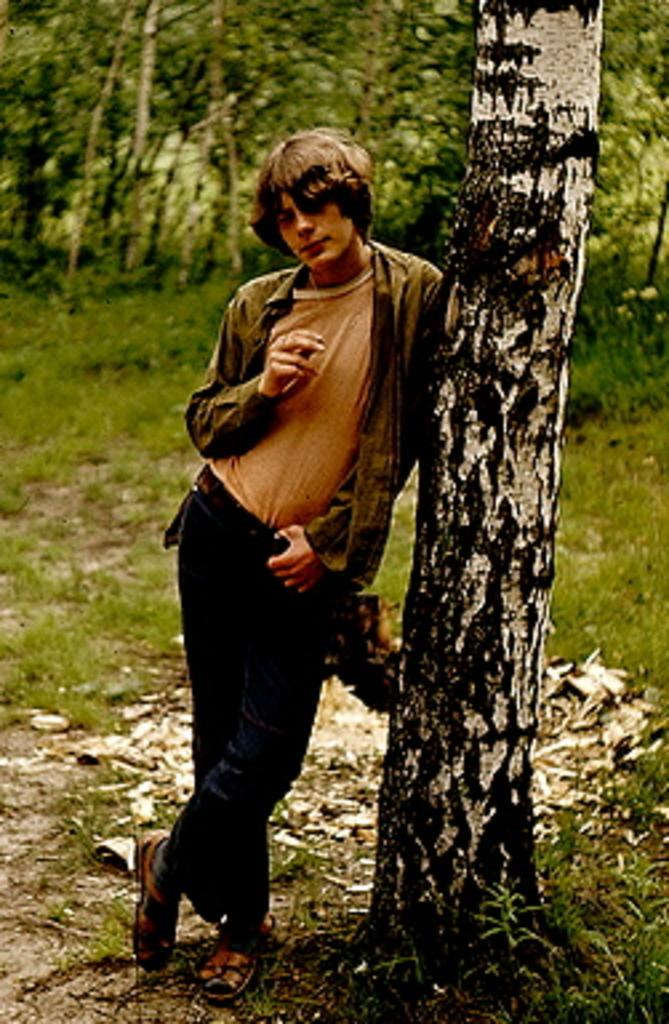What is the main subject of the image? There is a person standing in the image. What can be seen in the background of the image? There are trees in the background of the image. What type of vegetation is visible at the bottom of the image? Grass is visible at the bottom of the image. How does the person in the image pull the trees closer? The person in the image is not pulling the trees closer; they are simply standing in front of them. 